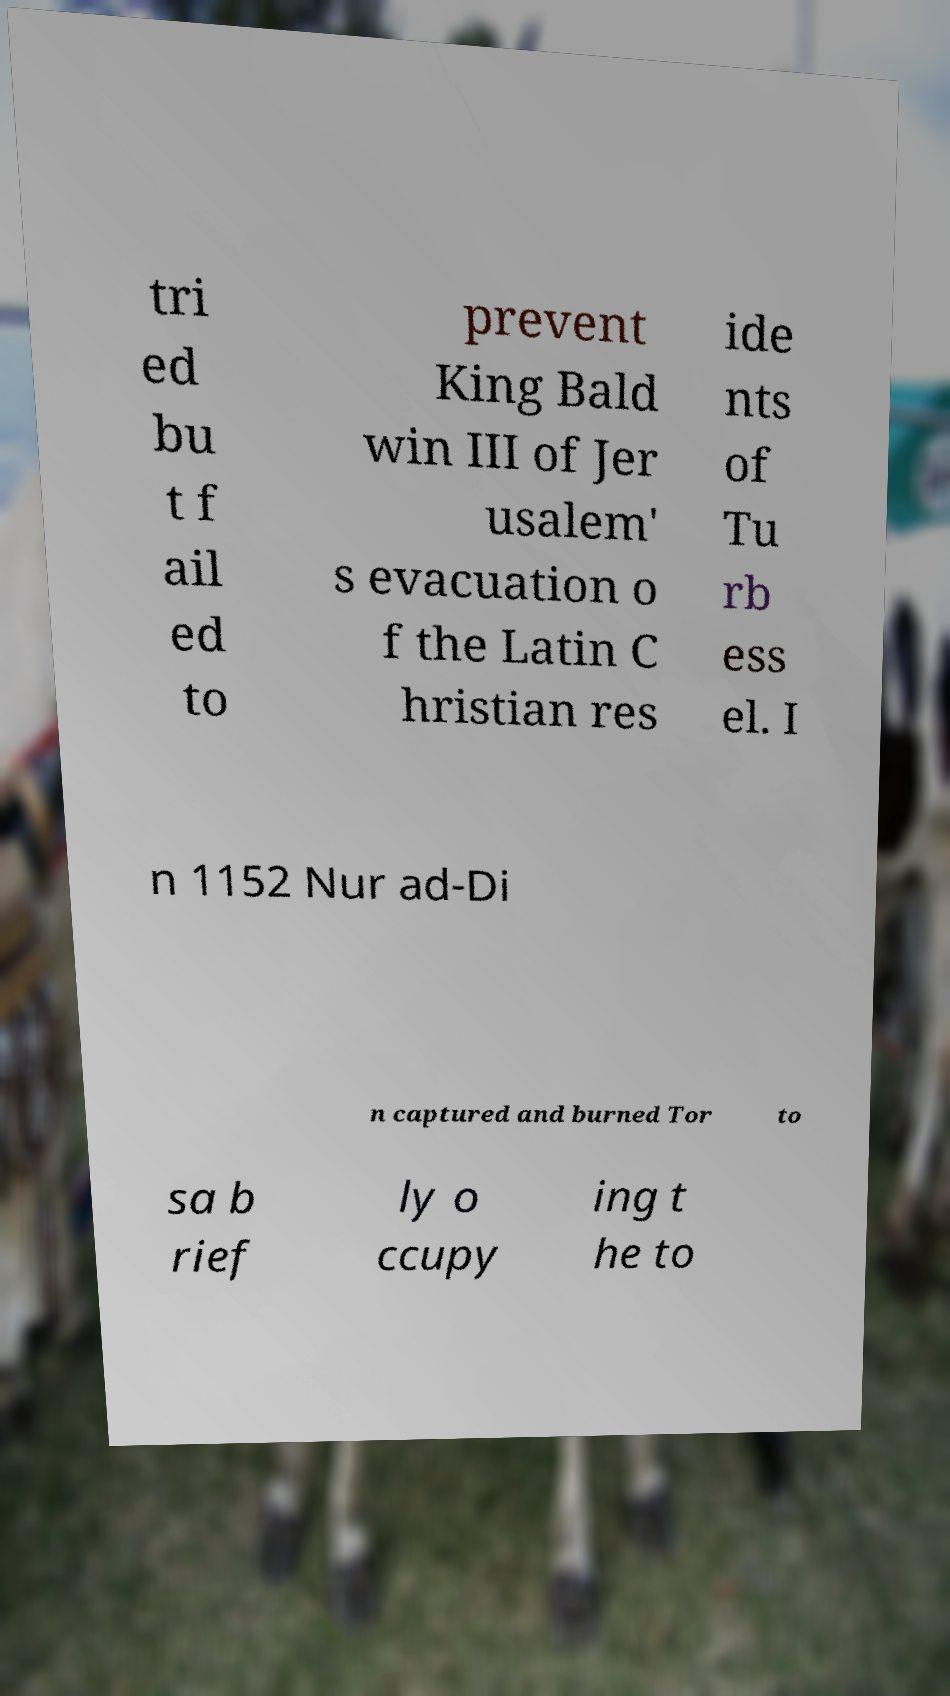Please identify and transcribe the text found in this image. tri ed bu t f ail ed to prevent King Bald win III of Jer usalem' s evacuation o f the Latin C hristian res ide nts of Tu rb ess el. I n 1152 Nur ad-Di n captured and burned Tor to sa b rief ly o ccupy ing t he to 